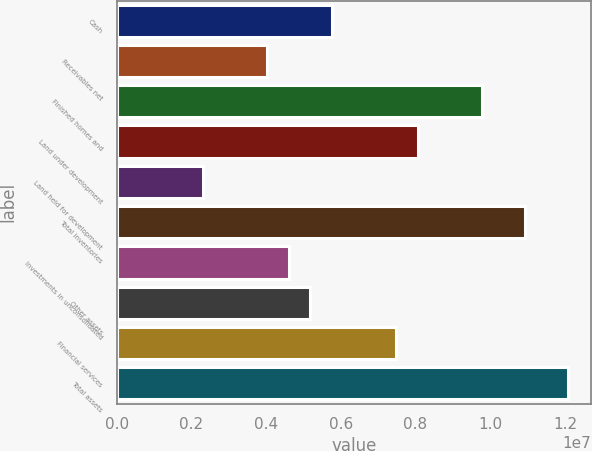<chart> <loc_0><loc_0><loc_500><loc_500><bar_chart><fcel>Cash<fcel>Receivables net<fcel>Finished homes and<fcel>Land under development<fcel>Land held for development<fcel>Total inventories<fcel>Investments in unconsolidated<fcel>Other assets<fcel>Financial services<fcel>Total assets<nl><fcel>5.75563e+06<fcel>4.02927e+06<fcel>9.7838e+06<fcel>8.05744e+06<fcel>2.30292e+06<fcel>1.09347e+07<fcel>4.60473e+06<fcel>5.18018e+06<fcel>7.48199e+06<fcel>1.20856e+07<nl></chart> 